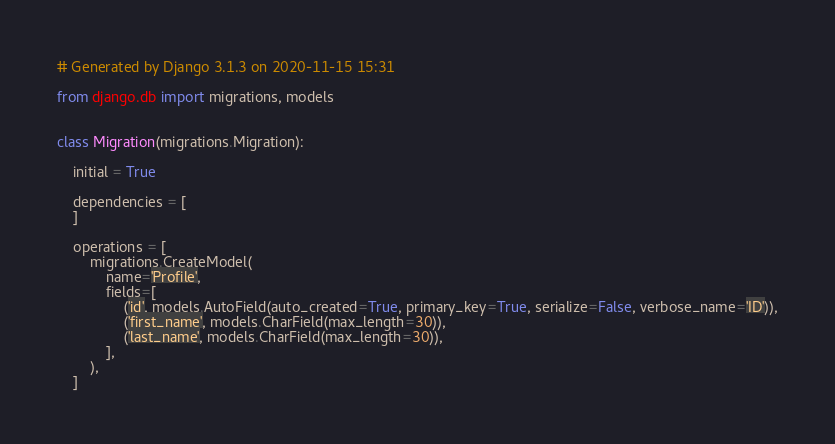<code> <loc_0><loc_0><loc_500><loc_500><_Python_># Generated by Django 3.1.3 on 2020-11-15 15:31

from django.db import migrations, models


class Migration(migrations.Migration):

    initial = True

    dependencies = [
    ]

    operations = [
        migrations.CreateModel(
            name='Profile',
            fields=[
                ('id', models.AutoField(auto_created=True, primary_key=True, serialize=False, verbose_name='ID')),
                ('first_name', models.CharField(max_length=30)),
                ('last_name', models.CharField(max_length=30)),
            ],
        ),
    ]
</code> 